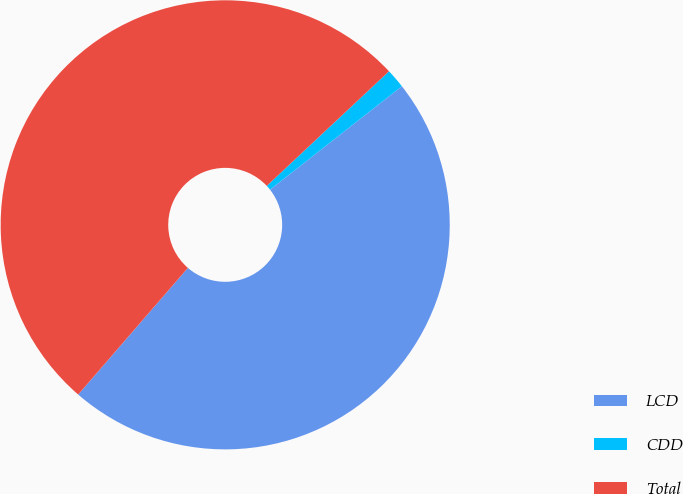Convert chart. <chart><loc_0><loc_0><loc_500><loc_500><pie_chart><fcel>LCD<fcel>CDD<fcel>Total<nl><fcel>46.95%<fcel>1.4%<fcel>51.65%<nl></chart> 